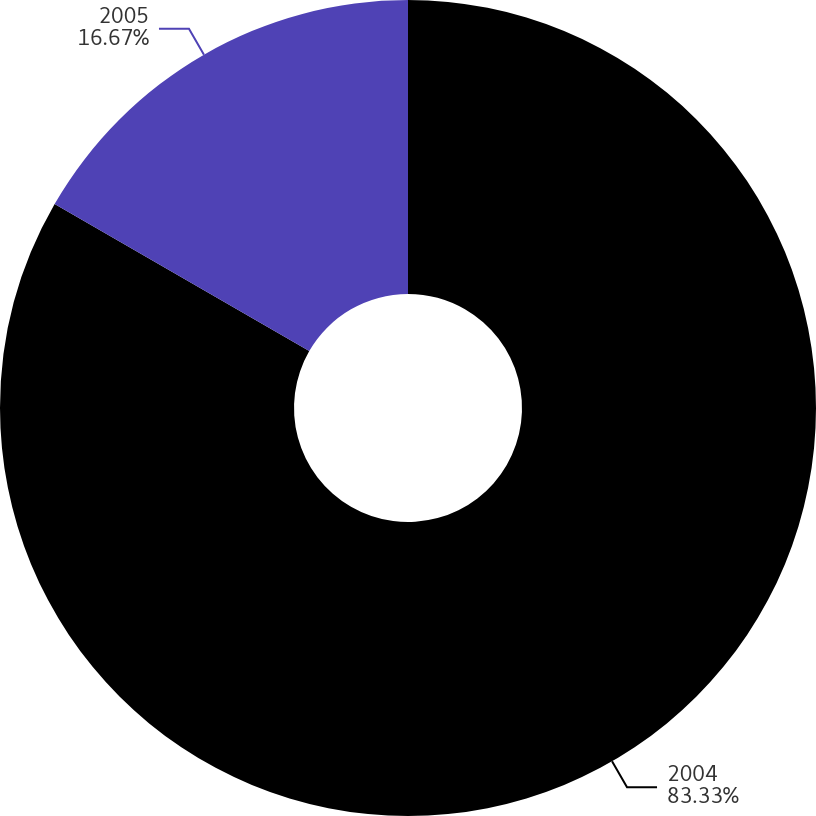Convert chart to OTSL. <chart><loc_0><loc_0><loc_500><loc_500><pie_chart><fcel>2004<fcel>2005<nl><fcel>83.33%<fcel>16.67%<nl></chart> 